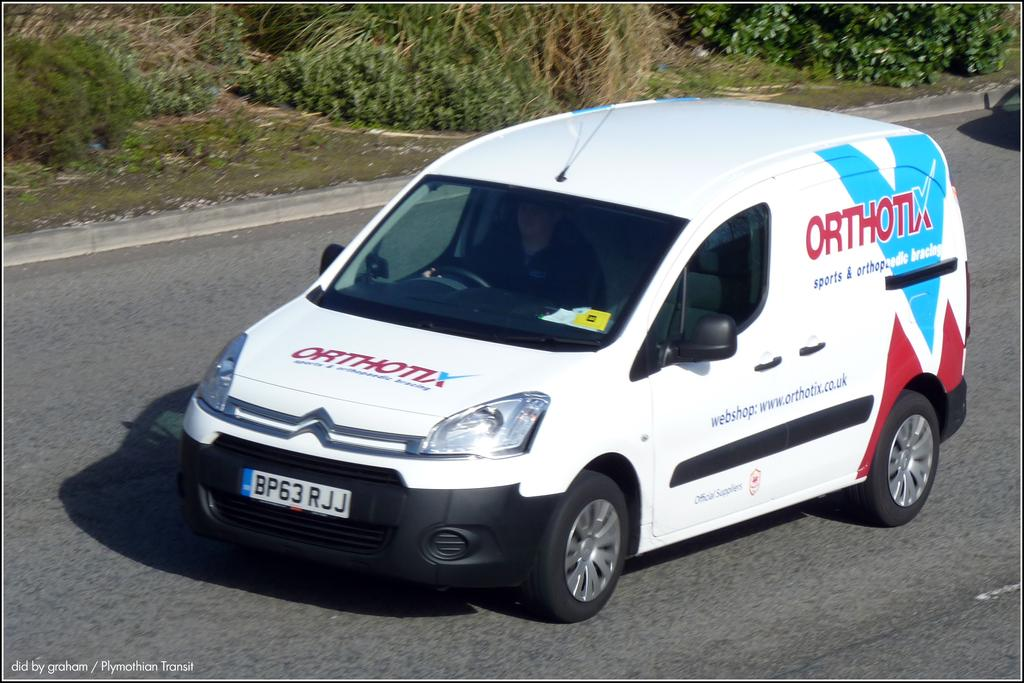<image>
Write a terse but informative summary of the picture. A white company van with the company logo Orthonx on the side of the van. 